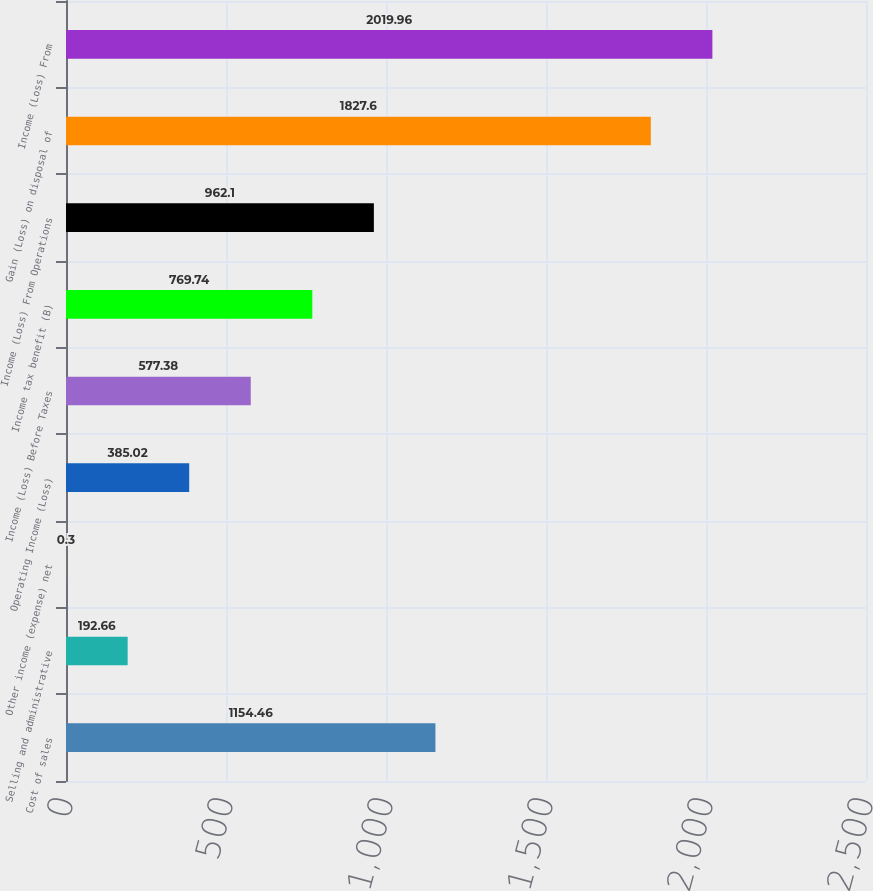<chart> <loc_0><loc_0><loc_500><loc_500><bar_chart><fcel>Cost of sales<fcel>Selling and administrative<fcel>Other income (expense) net<fcel>Operating Income (Loss)<fcel>Income (Loss) Before Taxes<fcel>Income tax benefit (B)<fcel>Income (Loss) From Operations<fcel>Gain (Loss) on disposal of<fcel>Income (Loss) From<nl><fcel>1154.46<fcel>192.66<fcel>0.3<fcel>385.02<fcel>577.38<fcel>769.74<fcel>962.1<fcel>1827.6<fcel>2019.96<nl></chart> 